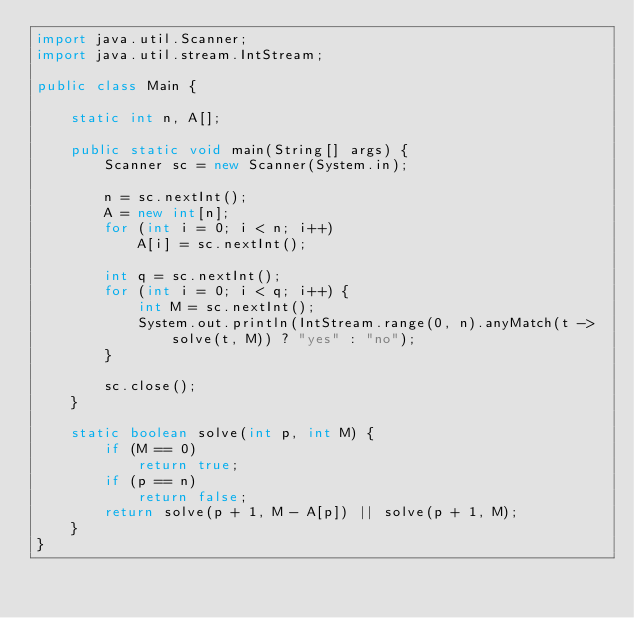Convert code to text. <code><loc_0><loc_0><loc_500><loc_500><_Java_>import java.util.Scanner;
import java.util.stream.IntStream;

public class Main {

	static int n, A[];

	public static void main(String[] args) {
		Scanner sc = new Scanner(System.in);

		n = sc.nextInt();
		A = new int[n];
		for (int i = 0; i < n; i++)
			A[i] = sc.nextInt();

		int q = sc.nextInt();
		for (int i = 0; i < q; i++) {
			int M = sc.nextInt();
			System.out.println(IntStream.range(0, n).anyMatch(t -> solve(t, M)) ? "yes" : "no");
		}

		sc.close();
	}

	static boolean solve(int p, int M) {
		if (M == 0)
			return true;
		if (p == n)
			return false;
		return solve(p + 1, M - A[p]) || solve(p + 1, M);
	}
}
</code> 